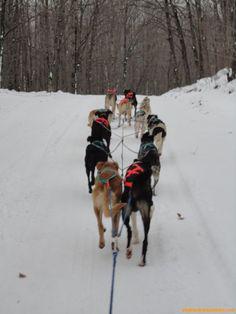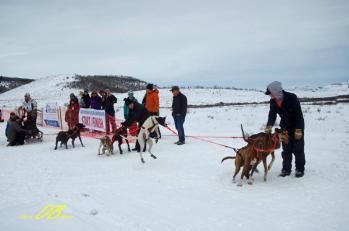The first image is the image on the left, the second image is the image on the right. Given the left and right images, does the statement "Each image shows a man in a numbered vest being pulled by a team of dogs moving forward." hold true? Answer yes or no. No. The first image is the image on the left, the second image is the image on the right. Evaluate the accuracy of this statement regarding the images: "A dog is up on its hind legs.". Is it true? Answer yes or no. Yes. 